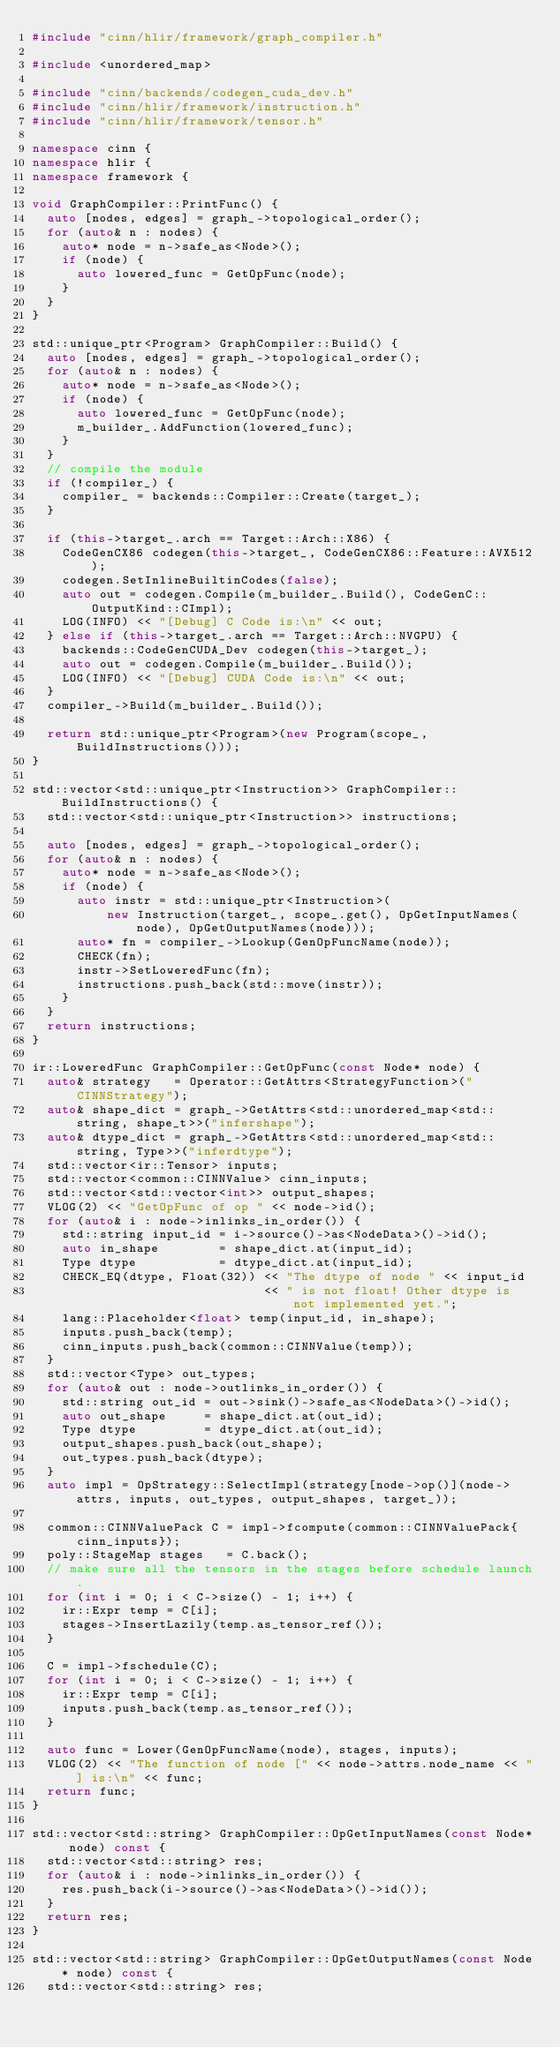<code> <loc_0><loc_0><loc_500><loc_500><_C++_>#include "cinn/hlir/framework/graph_compiler.h"

#include <unordered_map>

#include "cinn/backends/codegen_cuda_dev.h"
#include "cinn/hlir/framework/instruction.h"
#include "cinn/hlir/framework/tensor.h"

namespace cinn {
namespace hlir {
namespace framework {

void GraphCompiler::PrintFunc() {
  auto [nodes, edges] = graph_->topological_order();
  for (auto& n : nodes) {
    auto* node = n->safe_as<Node>();
    if (node) {
      auto lowered_func = GetOpFunc(node);
    }
  }
}

std::unique_ptr<Program> GraphCompiler::Build() {
  auto [nodes, edges] = graph_->topological_order();
  for (auto& n : nodes) {
    auto* node = n->safe_as<Node>();
    if (node) {
      auto lowered_func = GetOpFunc(node);
      m_builder_.AddFunction(lowered_func);
    }
  }
  // compile the module
  if (!compiler_) {
    compiler_ = backends::Compiler::Create(target_);
  }

  if (this->target_.arch == Target::Arch::X86) {
    CodeGenCX86 codegen(this->target_, CodeGenCX86::Feature::AVX512);
    codegen.SetInlineBuiltinCodes(false);
    auto out = codegen.Compile(m_builder_.Build(), CodeGenC::OutputKind::CImpl);
    LOG(INFO) << "[Debug] C Code is:\n" << out;
  } else if (this->target_.arch == Target::Arch::NVGPU) {
    backends::CodeGenCUDA_Dev codegen(this->target_);
    auto out = codegen.Compile(m_builder_.Build());
    LOG(INFO) << "[Debug] CUDA Code is:\n" << out;
  }
  compiler_->Build(m_builder_.Build());

  return std::unique_ptr<Program>(new Program(scope_, BuildInstructions()));
}

std::vector<std::unique_ptr<Instruction>> GraphCompiler::BuildInstructions() {
  std::vector<std::unique_ptr<Instruction>> instructions;

  auto [nodes, edges] = graph_->topological_order();
  for (auto& n : nodes) {
    auto* node = n->safe_as<Node>();
    if (node) {
      auto instr = std::unique_ptr<Instruction>(
          new Instruction(target_, scope_.get(), OpGetInputNames(node), OpGetOutputNames(node)));
      auto* fn = compiler_->Lookup(GenOpFuncName(node));
      CHECK(fn);
      instr->SetLoweredFunc(fn);
      instructions.push_back(std::move(instr));
    }
  }
  return instructions;
}

ir::LoweredFunc GraphCompiler::GetOpFunc(const Node* node) {
  auto& strategy   = Operator::GetAttrs<StrategyFunction>("CINNStrategy");
  auto& shape_dict = graph_->GetAttrs<std::unordered_map<std::string, shape_t>>("infershape");
  auto& dtype_dict = graph_->GetAttrs<std::unordered_map<std::string, Type>>("inferdtype");
  std::vector<ir::Tensor> inputs;
  std::vector<common::CINNValue> cinn_inputs;
  std::vector<std::vector<int>> output_shapes;
  VLOG(2) << "GetOpFunc of op " << node->id();
  for (auto& i : node->inlinks_in_order()) {
    std::string input_id = i->source()->as<NodeData>()->id();
    auto in_shape        = shape_dict.at(input_id);
    Type dtype           = dtype_dict.at(input_id);
    CHECK_EQ(dtype, Float(32)) << "The dtype of node " << input_id
                               << " is not float! Other dtype is not implemented yet.";
    lang::Placeholder<float> temp(input_id, in_shape);
    inputs.push_back(temp);
    cinn_inputs.push_back(common::CINNValue(temp));
  }
  std::vector<Type> out_types;
  for (auto& out : node->outlinks_in_order()) {
    std::string out_id = out->sink()->safe_as<NodeData>()->id();
    auto out_shape     = shape_dict.at(out_id);
    Type dtype         = dtype_dict.at(out_id);
    output_shapes.push_back(out_shape);
    out_types.push_back(dtype);
  }
  auto impl = OpStrategy::SelectImpl(strategy[node->op()](node->attrs, inputs, out_types, output_shapes, target_));

  common::CINNValuePack C = impl->fcompute(common::CINNValuePack{cinn_inputs});
  poly::StageMap stages   = C.back();
  // make sure all the tensors in the stages before schedule launch.
  for (int i = 0; i < C->size() - 1; i++) {
    ir::Expr temp = C[i];
    stages->InsertLazily(temp.as_tensor_ref());
  }

  C = impl->fschedule(C);
  for (int i = 0; i < C->size() - 1; i++) {
    ir::Expr temp = C[i];
    inputs.push_back(temp.as_tensor_ref());
  }

  auto func = Lower(GenOpFuncName(node), stages, inputs);
  VLOG(2) << "The function of node [" << node->attrs.node_name << "] is:\n" << func;
  return func;
}

std::vector<std::string> GraphCompiler::OpGetInputNames(const Node* node) const {
  std::vector<std::string> res;
  for (auto& i : node->inlinks_in_order()) {
    res.push_back(i->source()->as<NodeData>()->id());
  }
  return res;
}

std::vector<std::string> GraphCompiler::OpGetOutputNames(const Node* node) const {
  std::vector<std::string> res;</code> 